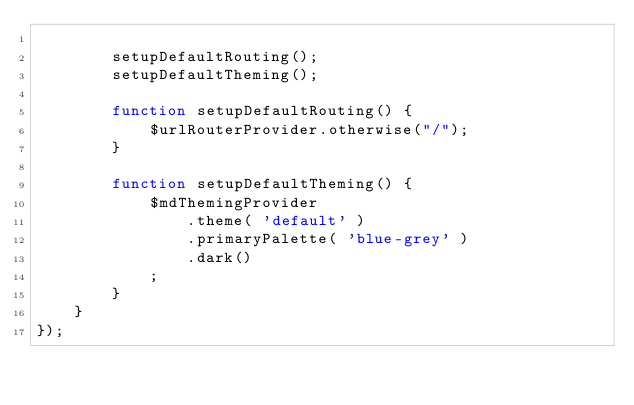<code> <loc_0><loc_0><loc_500><loc_500><_JavaScript_>
		setupDefaultRouting();
		setupDefaultTheming();

		function setupDefaultRouting() {
			$urlRouterProvider.otherwise("/");
		}

		function setupDefaultTheming() {
			$mdThemingProvider
				.theme( 'default' )
				.primaryPalette( 'blue-grey' )
				.dark()
			;
		}
	}
});</code> 